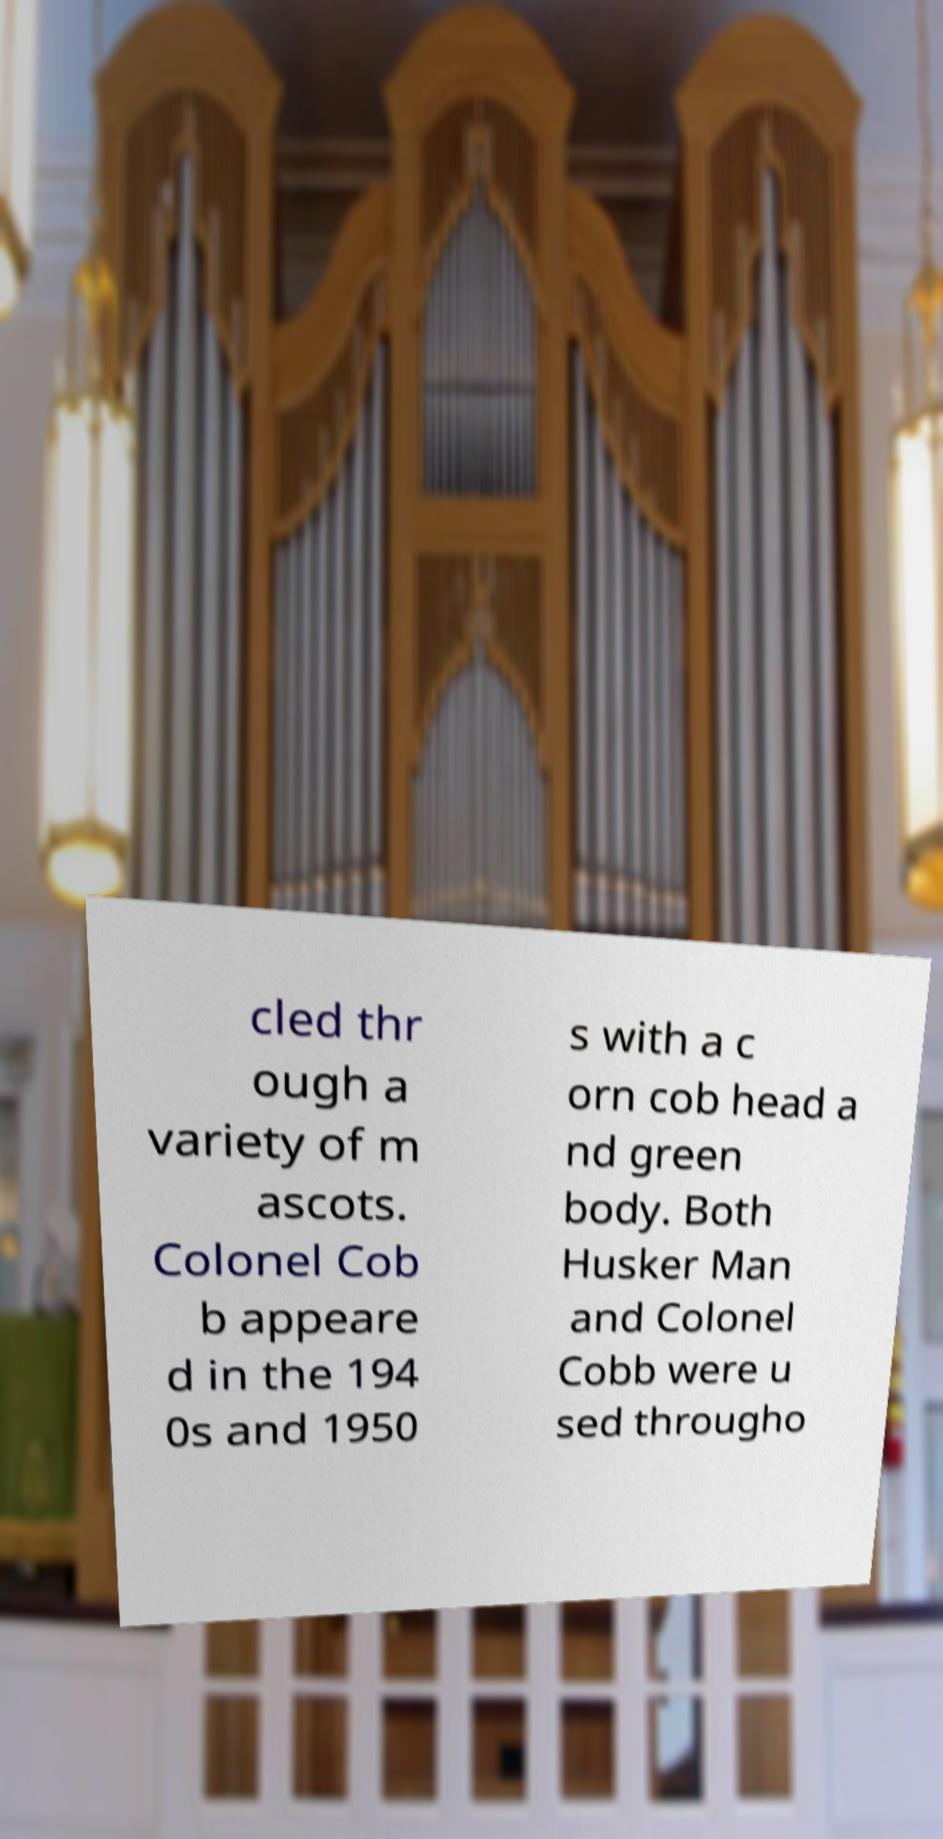Can you read and provide the text displayed in the image?This photo seems to have some interesting text. Can you extract and type it out for me? cled thr ough a variety of m ascots. Colonel Cob b appeare d in the 194 0s and 1950 s with a c orn cob head a nd green body. Both Husker Man and Colonel Cobb were u sed througho 